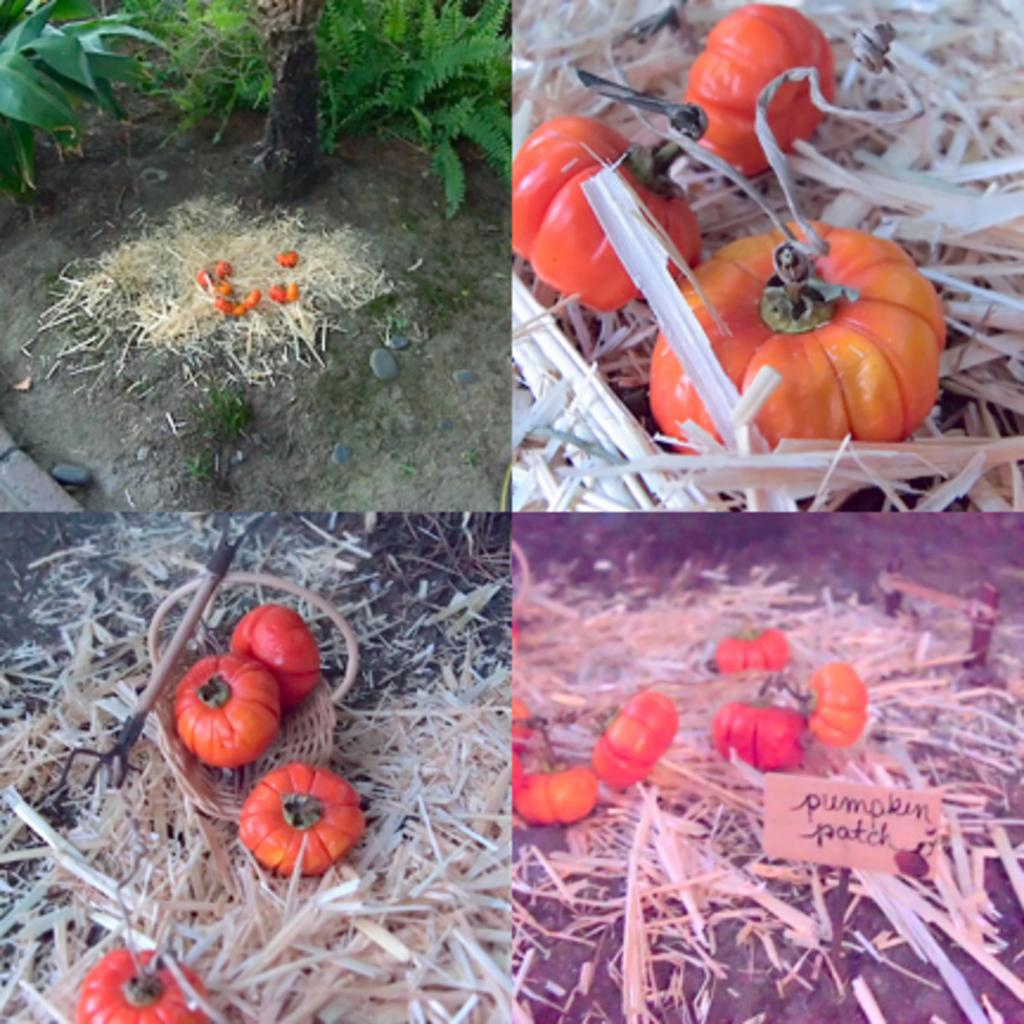What type of vegetable is present in the image? There are pumpkins in the image. Where are the pumpkins located? The pumpkins are placed on a lawn. What material can be seen in the image besides the pumpkins? There is straw in the image. What type of vegetation is present in the image besides the pumpkins? There are shrubs in the image. What object is present in the image that might be used for catching or holding? There is a net in the image. What type of drink is being served in the image? There is no drink present in the image; it features pumpkins, a lawn, straw, shrubs, and a net. What type of art can be seen in the image? There is no art present in the image; it features pumpkins, a lawn, straw, shrubs, and a net. 